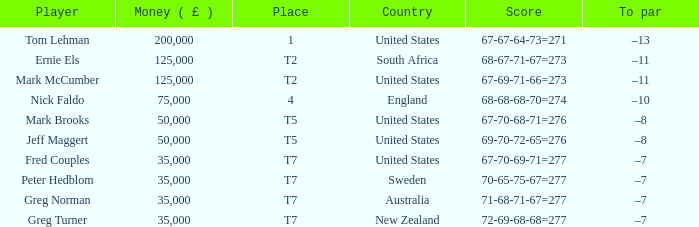Parse the table in full. {'header': ['Player', 'Money ( £ )', 'Place', 'Country', 'Score', 'To par'], 'rows': [['Tom Lehman', '200,000', '1', 'United States', '67-67-64-73=271', '–13'], ['Ernie Els', '125,000', 'T2', 'South Africa', '68-67-71-67=273', '–11'], ['Mark McCumber', '125,000', 'T2', 'United States', '67-69-71-66=273', '–11'], ['Nick Faldo', '75,000', '4', 'England', '68-68-68-70=274', '–10'], ['Mark Brooks', '50,000', 'T5', 'United States', '67-70-68-71=276', '–8'], ['Jeff Maggert', '50,000', 'T5', 'United States', '69-70-72-65=276', '–8'], ['Fred Couples', '35,000', 'T7', 'United States', '67-70-69-71=277', '–7'], ['Peter Hedblom', '35,000', 'T7', 'Sweden', '70-65-75-67=277', '–7'], ['Greg Norman', '35,000', 'T7', 'Australia', '71-68-71-67=277', '–7'], ['Greg Turner', '35,000', 'T7', 'New Zealand', '72-69-68-68=277', '–7']]} What is To par, when Country is "United States", when Money ( £ ) is greater than 125,000, and when Score is "67-70-68-71=276"? None. 